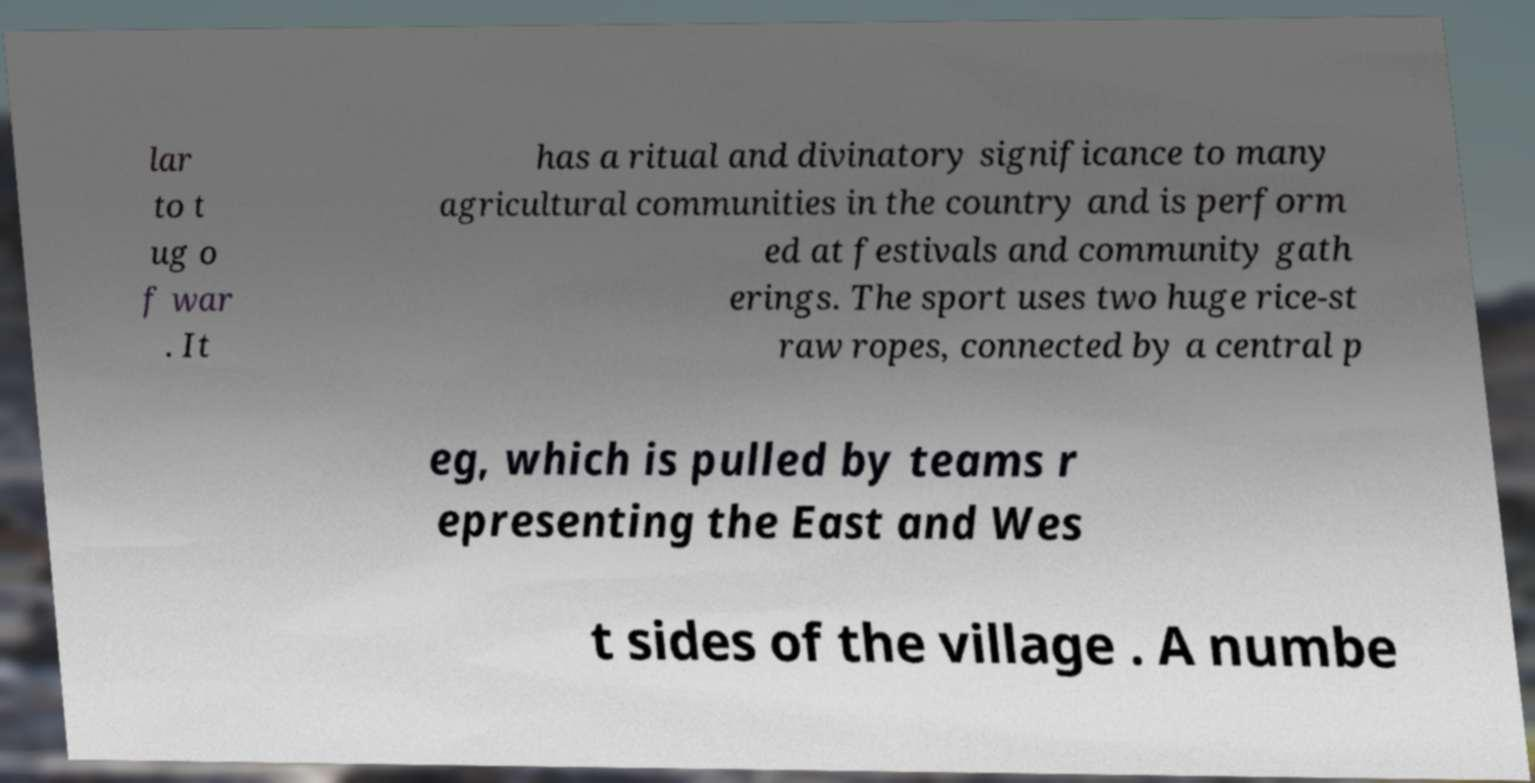What messages or text are displayed in this image? I need them in a readable, typed format. lar to t ug o f war . It has a ritual and divinatory significance to many agricultural communities in the country and is perform ed at festivals and community gath erings. The sport uses two huge rice-st raw ropes, connected by a central p eg, which is pulled by teams r epresenting the East and Wes t sides of the village . A numbe 